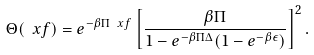Convert formula to latex. <formula><loc_0><loc_0><loc_500><loc_500>\Theta ( \ x f ) = e ^ { - \beta \Pi \ x f } \left [ \frac { \beta \Pi } { 1 - e ^ { - \beta \Pi \Delta } ( 1 - e ^ { - \beta \epsilon } ) } \right ] ^ { 2 } .</formula> 